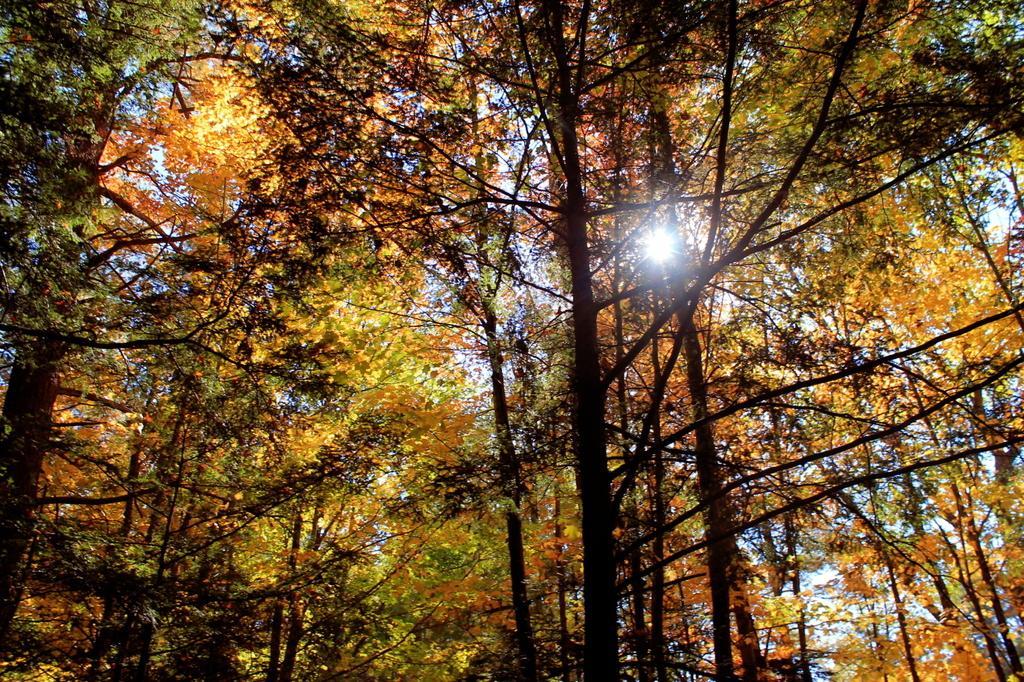In one or two sentences, can you explain what this image depicts? This image is taken outdoors. In this image there are many trees. In the background there is a sky with sun. 